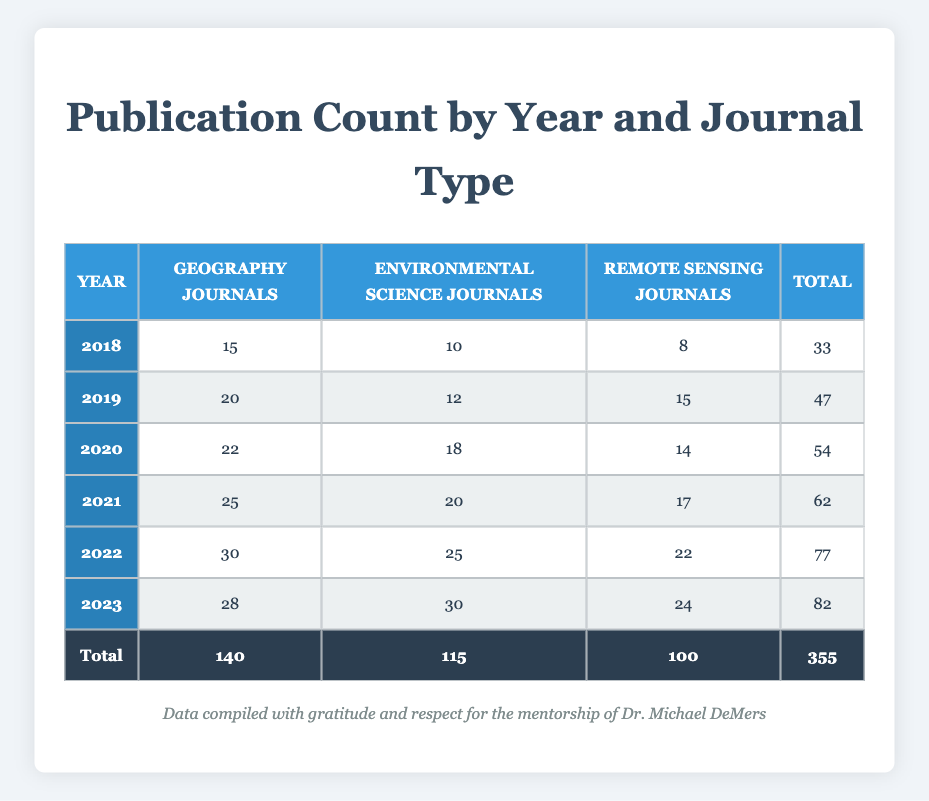What was the total publication count in 2021? To find the total publication count in 2021, we look at the row for 2021. The counts are 25 for Geography Journals, 20 for Environmental Science Journals, and 17 for Remote Sensing Journals. Summing these values gives us 25 + 20 + 17 = 62.
Answer: 62 Which journal type had the most publications in 2022? In the row for 2022, the publication counts are 30 for Geography Journals, 25 for Environmental Science Journals, and 22 for Remote Sensing Journals. The Geography Journals have the highest count of 30.
Answer: Geography Journals Was there an increase in publication count for Geography Journals from 2020 to 2021? The publication count for Geography Journals in 2020 is 22, and in 2021, it is 25. To determine if there is an increase, we can subtract 22 from 25, which results in an increase of 3.
Answer: Yes What is the average publication count across all years for Environmental Science Journals? First, we sum the publication counts for Environmental Science Journals from each year: 10 (2018) + 12 (2019) + 18 (2020) + 20 (2021) + 25 (2022) + 30 (2023) = 115. We have 6 years of data, so the average is computed as 115 / 6, which gives approximately 19.17.
Answer: 19.17 In which year was the total publication count the highest? We need to check the total publication counts for each year: 33 (2018), 47 (2019), 54 (2020), 62 (2021), 77 (2022), and 82 (2023). The highest total is 82 in 2023.
Answer: 2023 How many more publications were there in Remote Sensing Journals in 2019 than in 2020? The publication count for Remote Sensing Journals in 2019 is 15, while in 2020 it is 14. To find the difference, we subtract 14 from 15, resulting in a difference of 1.
Answer: 1 Did the publication count for Environmental Science Journals decrease from 2020 to 2021? The count in 2020 is 18 and in 2021 is 20. Since 20 is greater than 18, there was no decrease.
Answer: No What is the total publication count for all journal types in 2019? The publication counts for 2019 are 20 for Geography Journals, 12 for Environmental Science Journals, and 15 for Remote Sensing Journals. Adding these gives us 20 + 12 + 15 = 47.
Answer: 47 Which journal type showed the highest increase from 2018 to 2023? The increases are as follows: Geography Journals increased from 15 (2018) to 28 (2023) for an increase of 13. Environmental Science Journals increased from 10 (2018) to 30 (2023) for an increase of 20, and Remote Sensing Journals increased from 8 (2018) to 24 (2023) for an increase of 16. The highest increase is 20 for Environmental Science Journals.
Answer: Environmental Science Journals 